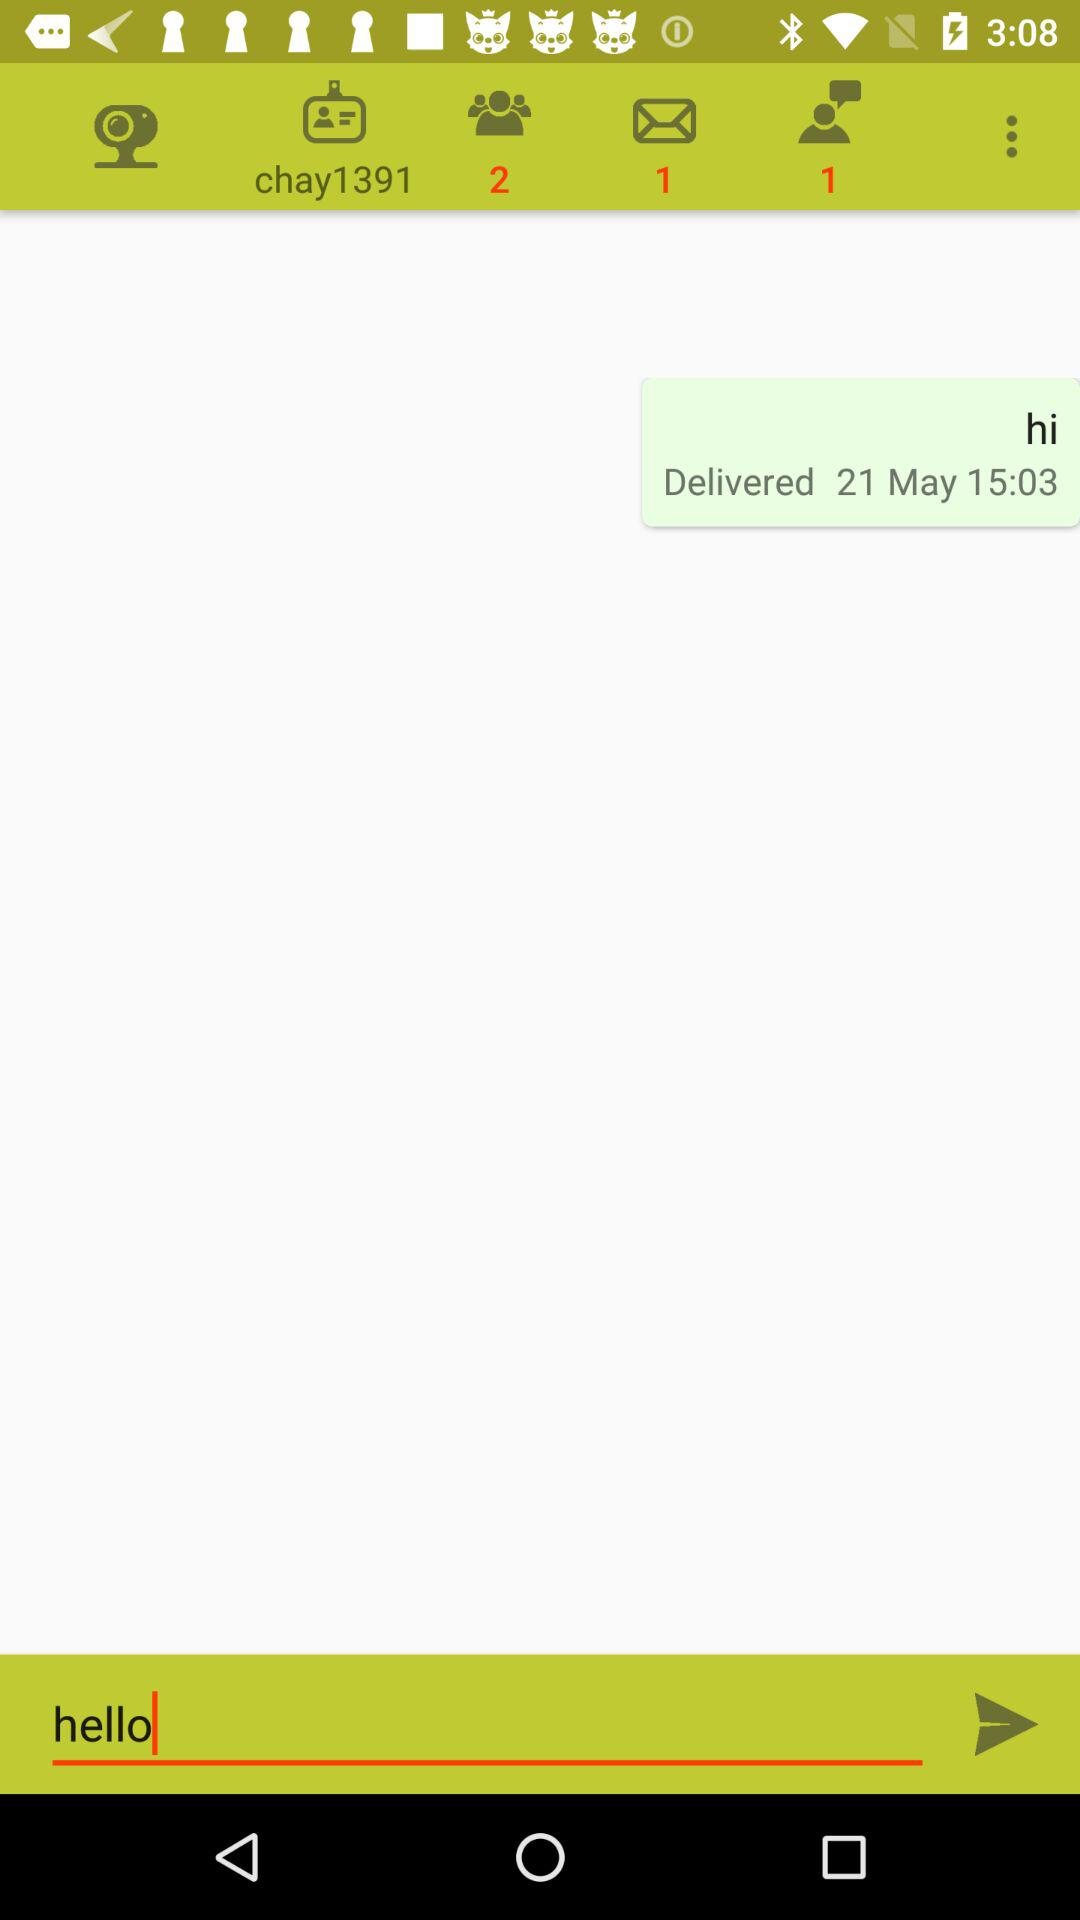How many messages are unread? There is 1 unread message. 